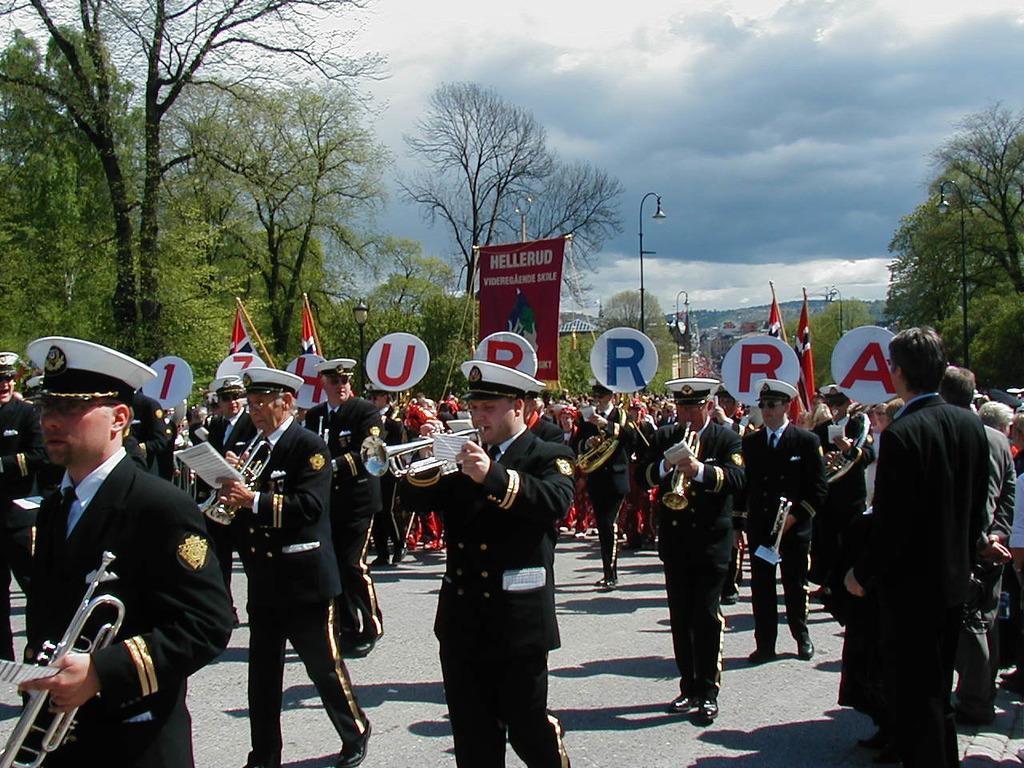Can you describe this image briefly? In this image I can see number of people are standing, I can see all of them are holding musical instruments and I can see all of them are wearing uniforms. I can also see all of them are wearing caps. In the background I can see number of boards, few flags, few poles, number of trees, few lights, clouds, the sky and on these boards I can see something is written. 